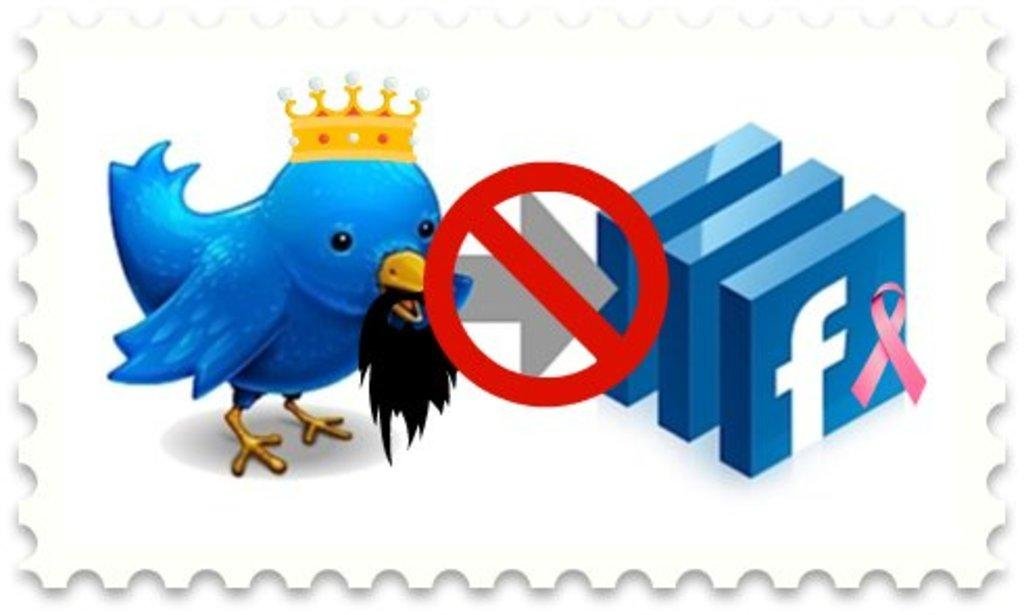What type of animal is in the picture? There is a bird in the picture. Can you describe any unique features of the bird? The bird has a crown. What else can be seen in the picture besides the bird? There are symbols and signs in the picture. What type of footwear is the mom wearing in the picture? There is no mom or footwear present in the image; it features a bird with a crown and symbols and signs. 